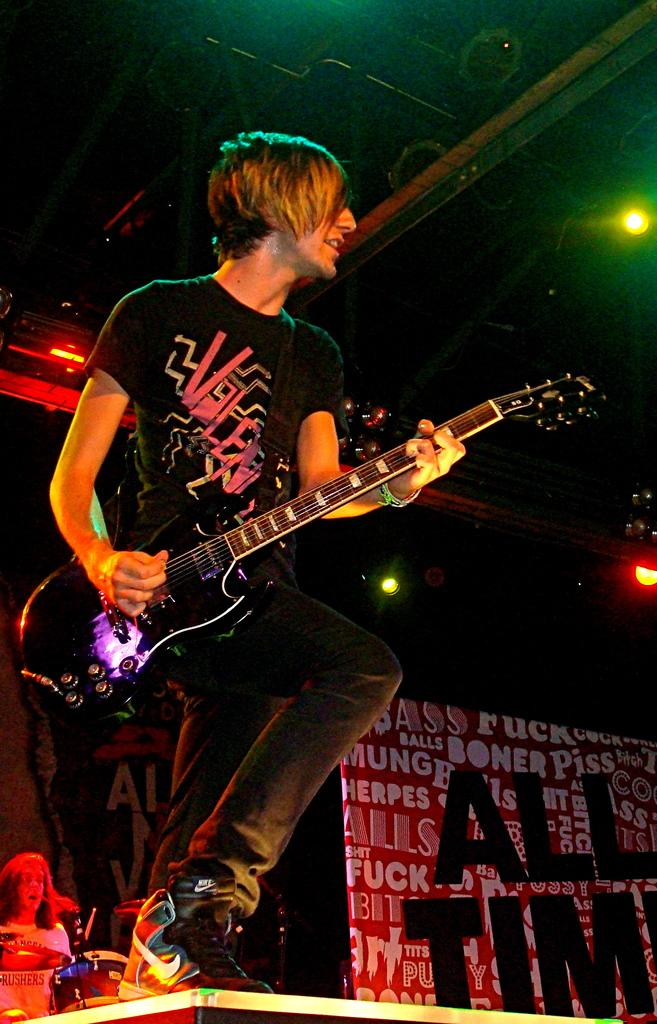What is the main activity of the person in the image? The person in the image is playing the guitar. Where is the person playing the guitar located? The person is on a stage. Are there any other musicians in the image? Yes, there is another person playing the drums in the image. What can be inferred about the lighting conditions in the image? The background of the image is dark, which suggests that the lighting may be dim or focused on the stage. What type of tree can be seen in the background of the image? There is no tree visible in the background of the image; it is dark. What class is the person teaching in the image? There is no class or teaching activity depicted in the image; it features musicians on a stage. 